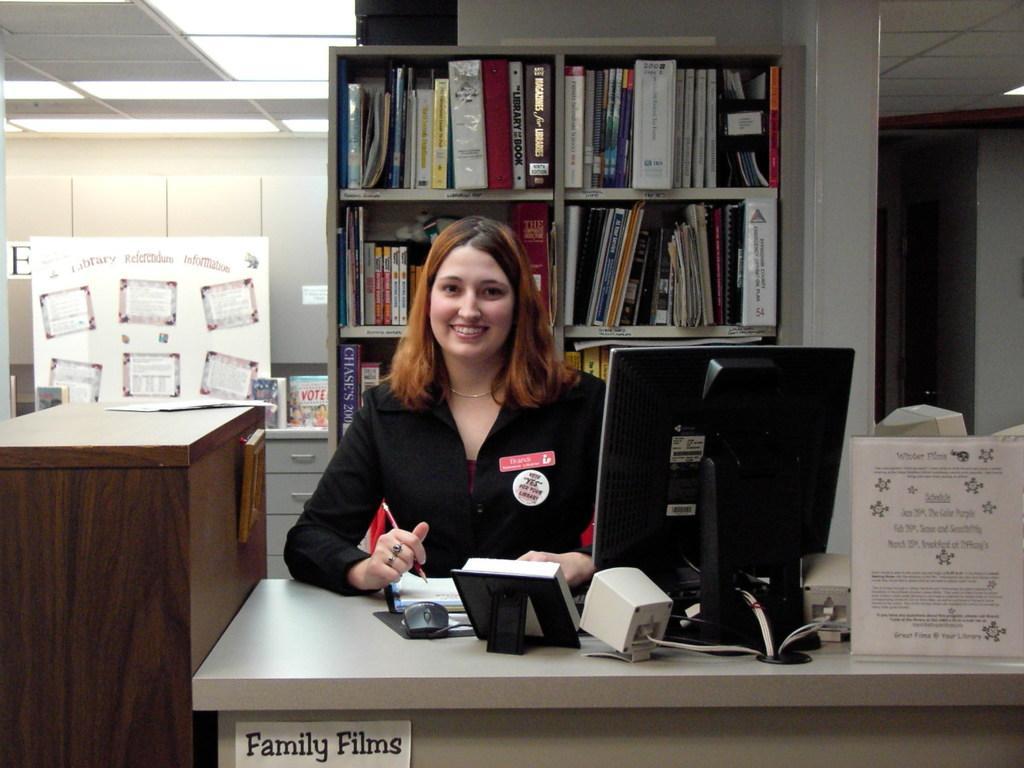Could you give a brief overview of what you see in this image? In this image there is a person sitting on the chair and she is holding the pen. In front of her there is a table. On top of it there is a book, computer, photo frames and a few other objects. Behind her there are books on the rack. Beside her there is a wooden table. On top of it there is a paper. In the background of the image there are books on the table. There is a wall. On top of the image there are lights. 